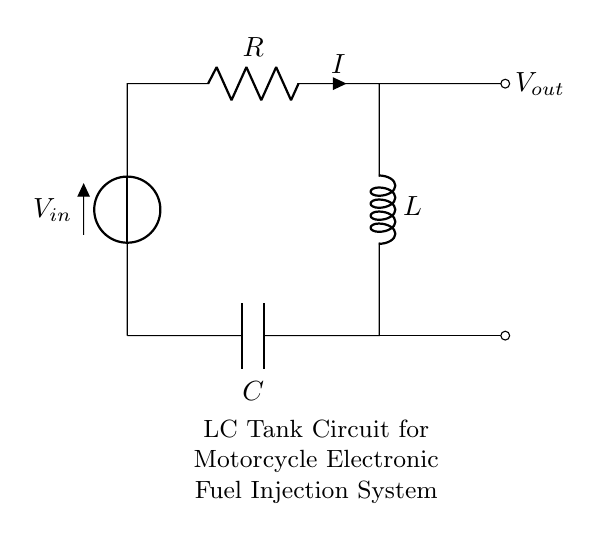What are the components in this circuit? The circuit consists of a resistor, inductor, and capacitor arranged in a loop. The names of the components can be seen labeled directly in the diagram.
Answer: resistor, inductor, capacitor What is the purpose of the capacitor in this circuit? The capacitor in an LC tank circuit is used to store electrical energy temporarily and can help with the oscillation and filtering characteristics which are crucial in electronic fuel injection systems.
Answer: energy storage What is the voltage source in this circuit? The voltage source is labeled as V in the circuit diagram and represents the input voltage to the LC tank circuit necessary for operation.
Answer: V_in What is the current flowing through the resistor? The current through the resistor, represented by 'I' in the circuit, is dependent on the values of the components and the supply voltage. However, since it is indicated and labeled, we can refer to it as 'I'.
Answer: I Explain the relationship between the inductor and capacitor in this circuit. The inductor and capacitor together form the tank of the LC circuit, capable of resonating at a specific frequency determined by their values. When energy oscillates between them, it creates a reactive circuit that stores and releases energy, important for the modulation of fuel injection.
Answer: resonant frequency What happens to the output voltage when the circuit reaches resonance? At resonance in an LC tank circuit, the output voltage is maximized because the impedance in the circuit is minimized, allowing maximum energy transfer and oscillation. This behavior is critical in ensuring proper operation of electronic fuel injection systems.
Answer: maximized output voltage What type of circuit is this classified as? This circuit is classified as a tank circuit or resonant circuit because it stores energy in the inductor and capacitor and can create oscillations, important for applications like fuel injection.
Answer: tank circuit 